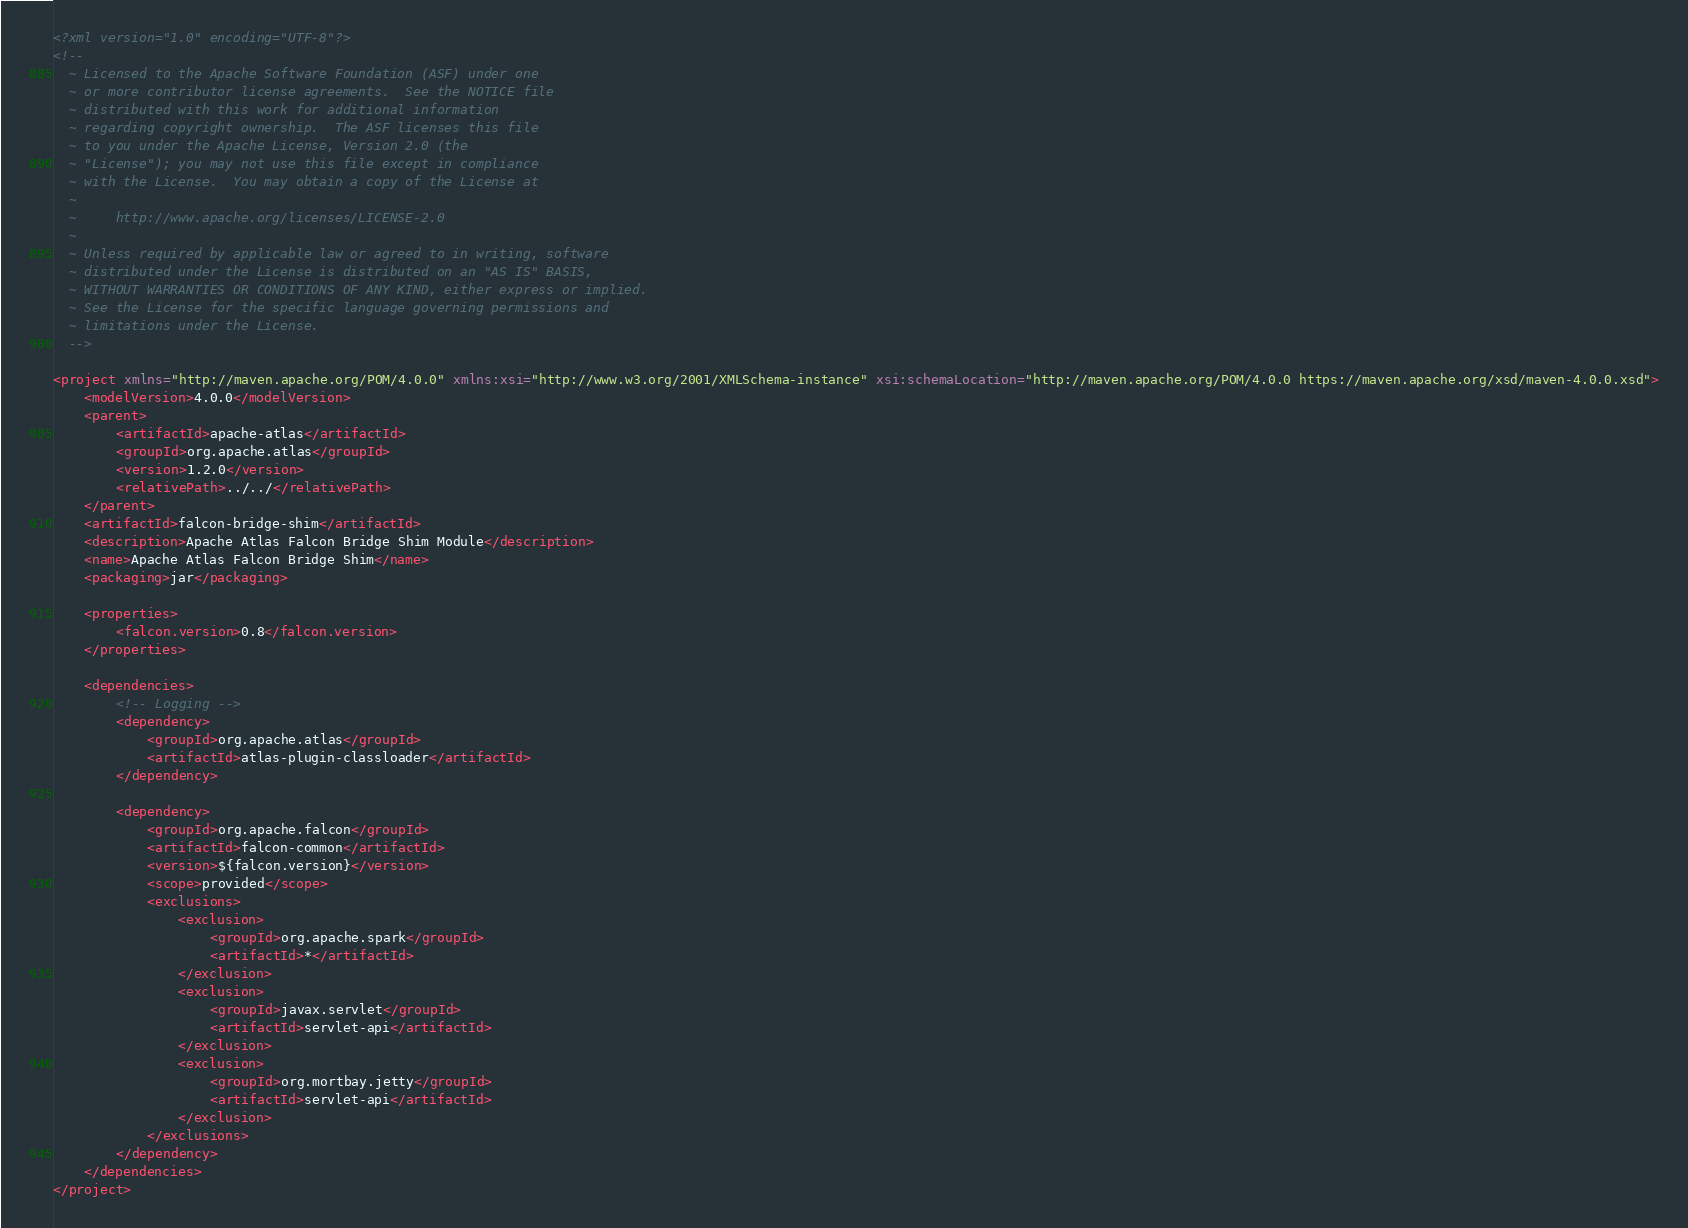<code> <loc_0><loc_0><loc_500><loc_500><_XML_><?xml version="1.0" encoding="UTF-8"?>
<!--
  ~ Licensed to the Apache Software Foundation (ASF) under one
  ~ or more contributor license agreements.  See the NOTICE file
  ~ distributed with this work for additional information
  ~ regarding copyright ownership.  The ASF licenses this file
  ~ to you under the Apache License, Version 2.0 (the
  ~ "License"); you may not use this file except in compliance
  ~ with the License.  You may obtain a copy of the License at
  ~
  ~     http://www.apache.org/licenses/LICENSE-2.0
  ~
  ~ Unless required by applicable law or agreed to in writing, software
  ~ distributed under the License is distributed on an "AS IS" BASIS,
  ~ WITHOUT WARRANTIES OR CONDITIONS OF ANY KIND, either express or implied.
  ~ See the License for the specific language governing permissions and
  ~ limitations under the License.
  -->

<project xmlns="http://maven.apache.org/POM/4.0.0" xmlns:xsi="http://www.w3.org/2001/XMLSchema-instance" xsi:schemaLocation="http://maven.apache.org/POM/4.0.0 https://maven.apache.org/xsd/maven-4.0.0.xsd">
    <modelVersion>4.0.0</modelVersion>
    <parent>
        <artifactId>apache-atlas</artifactId>
        <groupId>org.apache.atlas</groupId>
        <version>1.2.0</version>
        <relativePath>../../</relativePath>
    </parent>
    <artifactId>falcon-bridge-shim</artifactId>
    <description>Apache Atlas Falcon Bridge Shim Module</description>
    <name>Apache Atlas Falcon Bridge Shim</name>
    <packaging>jar</packaging>

    <properties>
        <falcon.version>0.8</falcon.version>
    </properties>

    <dependencies>
        <!-- Logging -->
        <dependency>
            <groupId>org.apache.atlas</groupId>
            <artifactId>atlas-plugin-classloader</artifactId>
        </dependency>

        <dependency>
            <groupId>org.apache.falcon</groupId>
            <artifactId>falcon-common</artifactId>
            <version>${falcon.version}</version>
            <scope>provided</scope>
            <exclusions>
                <exclusion>
                    <groupId>org.apache.spark</groupId>
                    <artifactId>*</artifactId>
                </exclusion>
                <exclusion>
                    <groupId>javax.servlet</groupId>
                    <artifactId>servlet-api</artifactId>
                </exclusion>
                <exclusion>
                    <groupId>org.mortbay.jetty</groupId>
                    <artifactId>servlet-api</artifactId>
                </exclusion>
            </exclusions>
        </dependency>
    </dependencies>
</project>
</code> 